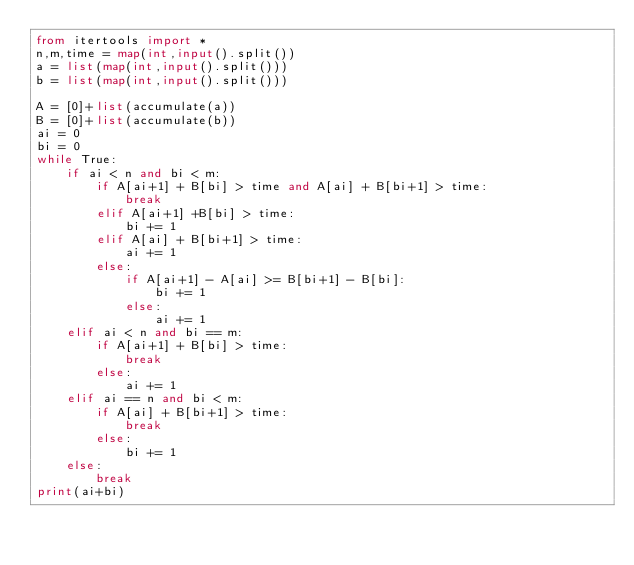Convert code to text. <code><loc_0><loc_0><loc_500><loc_500><_Python_>from itertools import *
n,m,time = map(int,input().split())
a = list(map(int,input().split()))
b = list(map(int,input().split()))

A = [0]+list(accumulate(a))
B = [0]+list(accumulate(b))
ai = 0
bi = 0
while True:
    if ai < n and bi < m:
        if A[ai+1] + B[bi] > time and A[ai] + B[bi+1] > time:
            break
        elif A[ai+1] +B[bi] > time:
            bi += 1
        elif A[ai] + B[bi+1] > time:
            ai += 1
        else:
            if A[ai+1] - A[ai] >= B[bi+1] - B[bi]:
                bi += 1
            else:
                ai += 1
    elif ai < n and bi == m:
        if A[ai+1] + B[bi] > time:
            break
        else:
            ai += 1
    elif ai == n and bi < m:
        if A[ai] + B[bi+1] > time:
            break
        else:
            bi += 1
    else:
        break
print(ai+bi)</code> 